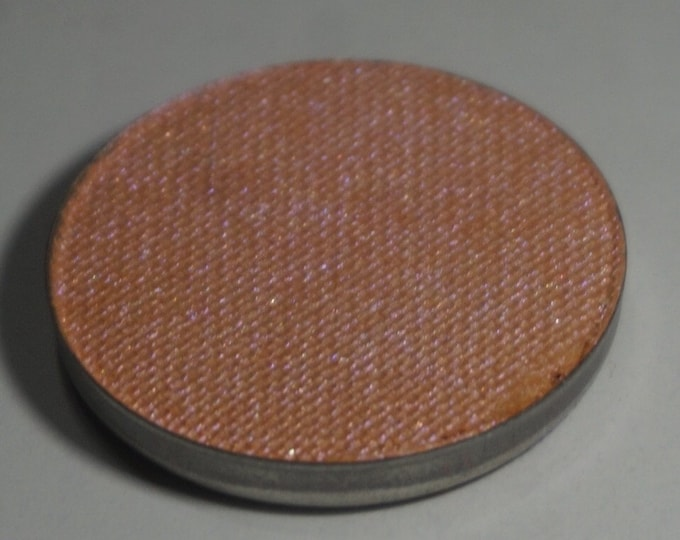Imagine this disc is part of a hidden treasure's map. How would it be used? In a hidden treasure's map, this disc could serve as the key to unlocking the final clue. Perhaps when held up to the sunlight at a particular time of day, it projects an image or reveals hidden writing on a wall, indicating the treasure's location. The weave pattern might match an ancient artifact, requiring the explorer to place it onto a corresponding stone tablet to complete the puzzle. This interaction activates a mechanism that uncovers the treasure chamber. The disc's durable yet lightweight nature makes it a portable and essential tool for the adventurous treasure seeker. Can you write a short story about this treasure map adventure? In an ancient library, Emma discovered an old parchment hinting at hidden treasure. The parchment described a disc with a unique woven texture, saying it was the key. After months of searching, she found the disc in an antique shop. Guided by the map, she traveled to an ancient ruin. At noon, she held the disc to the light, and it projected a constellation onto the ground. The constellation pointed the way to a specific stone tablet deep within the ruins. Placing the disc on the tablet, gears began to turn, and a hidden passage opened. Inside, she found a trove of priceless artifacts and scrolls, a discovery that would rewrite history. Emma's find was hailed as the greatest archaeological discovery of her time, all thanks to the mysterious disc. 